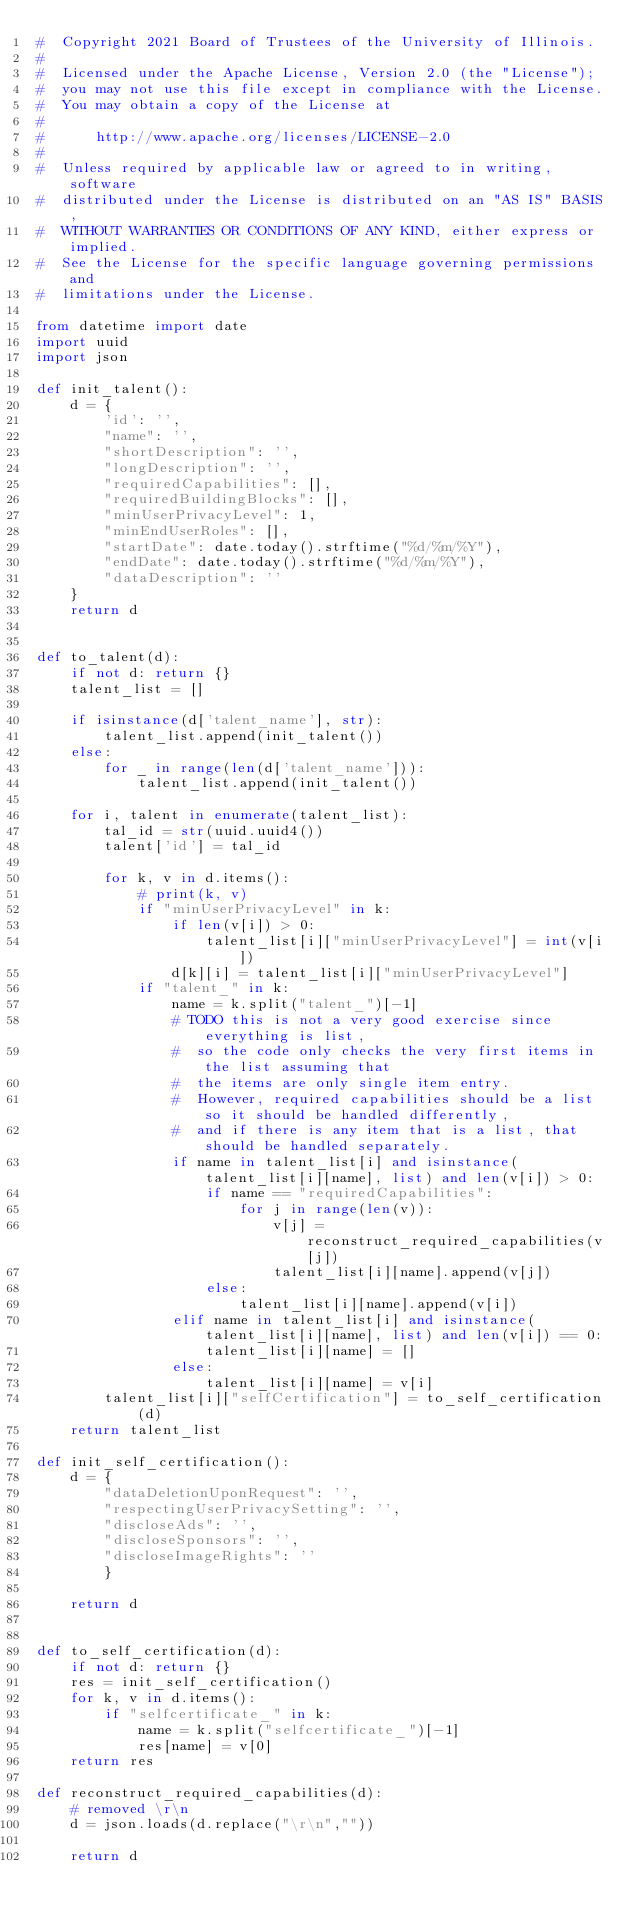Convert code to text. <code><loc_0><loc_0><loc_500><loc_500><_Python_>#  Copyright 2021 Board of Trustees of the University of Illinois.
#
#  Licensed under the Apache License, Version 2.0 (the "License");
#  you may not use this file except in compliance with the License.
#  You may obtain a copy of the License at
#
#      http://www.apache.org/licenses/LICENSE-2.0
#
#  Unless required by applicable law or agreed to in writing, software
#  distributed under the License is distributed on an "AS IS" BASIS,
#  WITHOUT WARRANTIES OR CONDITIONS OF ANY KIND, either express or implied.
#  See the License for the specific language governing permissions and
#  limitations under the License.

from datetime import date
import uuid
import json

def init_talent():
    d = {
        'id': '',
        "name": '',
        "shortDescription": '',
        "longDescription": '',
        "requiredCapabilities": [],
        "requiredBuildingBlocks": [],
        "minUserPrivacyLevel": 1,
        "minEndUserRoles": [],
        "startDate": date.today().strftime("%d/%m/%Y"),
        "endDate": date.today().strftime("%d/%m/%Y"),
        "dataDescription": ''
    }
    return d


def to_talent(d):
    if not d: return {}
    talent_list = []

    if isinstance(d['talent_name'], str):
        talent_list.append(init_talent())
    else:
        for _ in range(len(d['talent_name'])):
            talent_list.append(init_talent())

    for i, talent in enumerate(talent_list):
        tal_id = str(uuid.uuid4())
        talent['id'] = tal_id

        for k, v in d.items():
            # print(k, v)
            if "minUserPrivacyLevel" in k:
                if len(v[i]) > 0:
                    talent_list[i]["minUserPrivacyLevel"] = int(v[i])
                d[k][i] = talent_list[i]["minUserPrivacyLevel"]
            if "talent_" in k:
                name = k.split("talent_")[-1]
                # TODO this is not a very good exercise since everything is list,
                #  so the code only checks the very first items in the list assuming that
                #  the items are only single item entry.
                #  However, required capabilities should be a list so it should be handled differently,
                #  and if there is any item that is a list, that should be handled separately.
                if name in talent_list[i] and isinstance(talent_list[i][name], list) and len(v[i]) > 0:
                    if name == "requiredCapabilities":
                        for j in range(len(v)):
                            v[j] = reconstruct_required_capabilities(v[j])
                            talent_list[i][name].append(v[j])
                    else:
                        talent_list[i][name].append(v[i])
                elif name in talent_list[i] and isinstance(talent_list[i][name], list) and len(v[i]) == 0:
                    talent_list[i][name] = []
                else:
                    talent_list[i][name] = v[i]
        talent_list[i]["selfCertification"] = to_self_certification(d)
    return talent_list

def init_self_certification():
    d = {
        "dataDeletionUponRequest": '',
        "respectingUserPrivacySetting": '',
        "discloseAds": '',
        "discloseSponsors": '',
        "discloseImageRights": ''
        }

    return d


def to_self_certification(d):
    if not d: return {}
    res = init_self_certification()
    for k, v in d.items():
        if "selfcertificate_" in k:
            name = k.split("selfcertificate_")[-1]
            res[name] = v[0]
    return res

def reconstruct_required_capabilities(d):
    # removed \r\n
    d = json.loads(d.replace("\r\n",""))

    return d</code> 